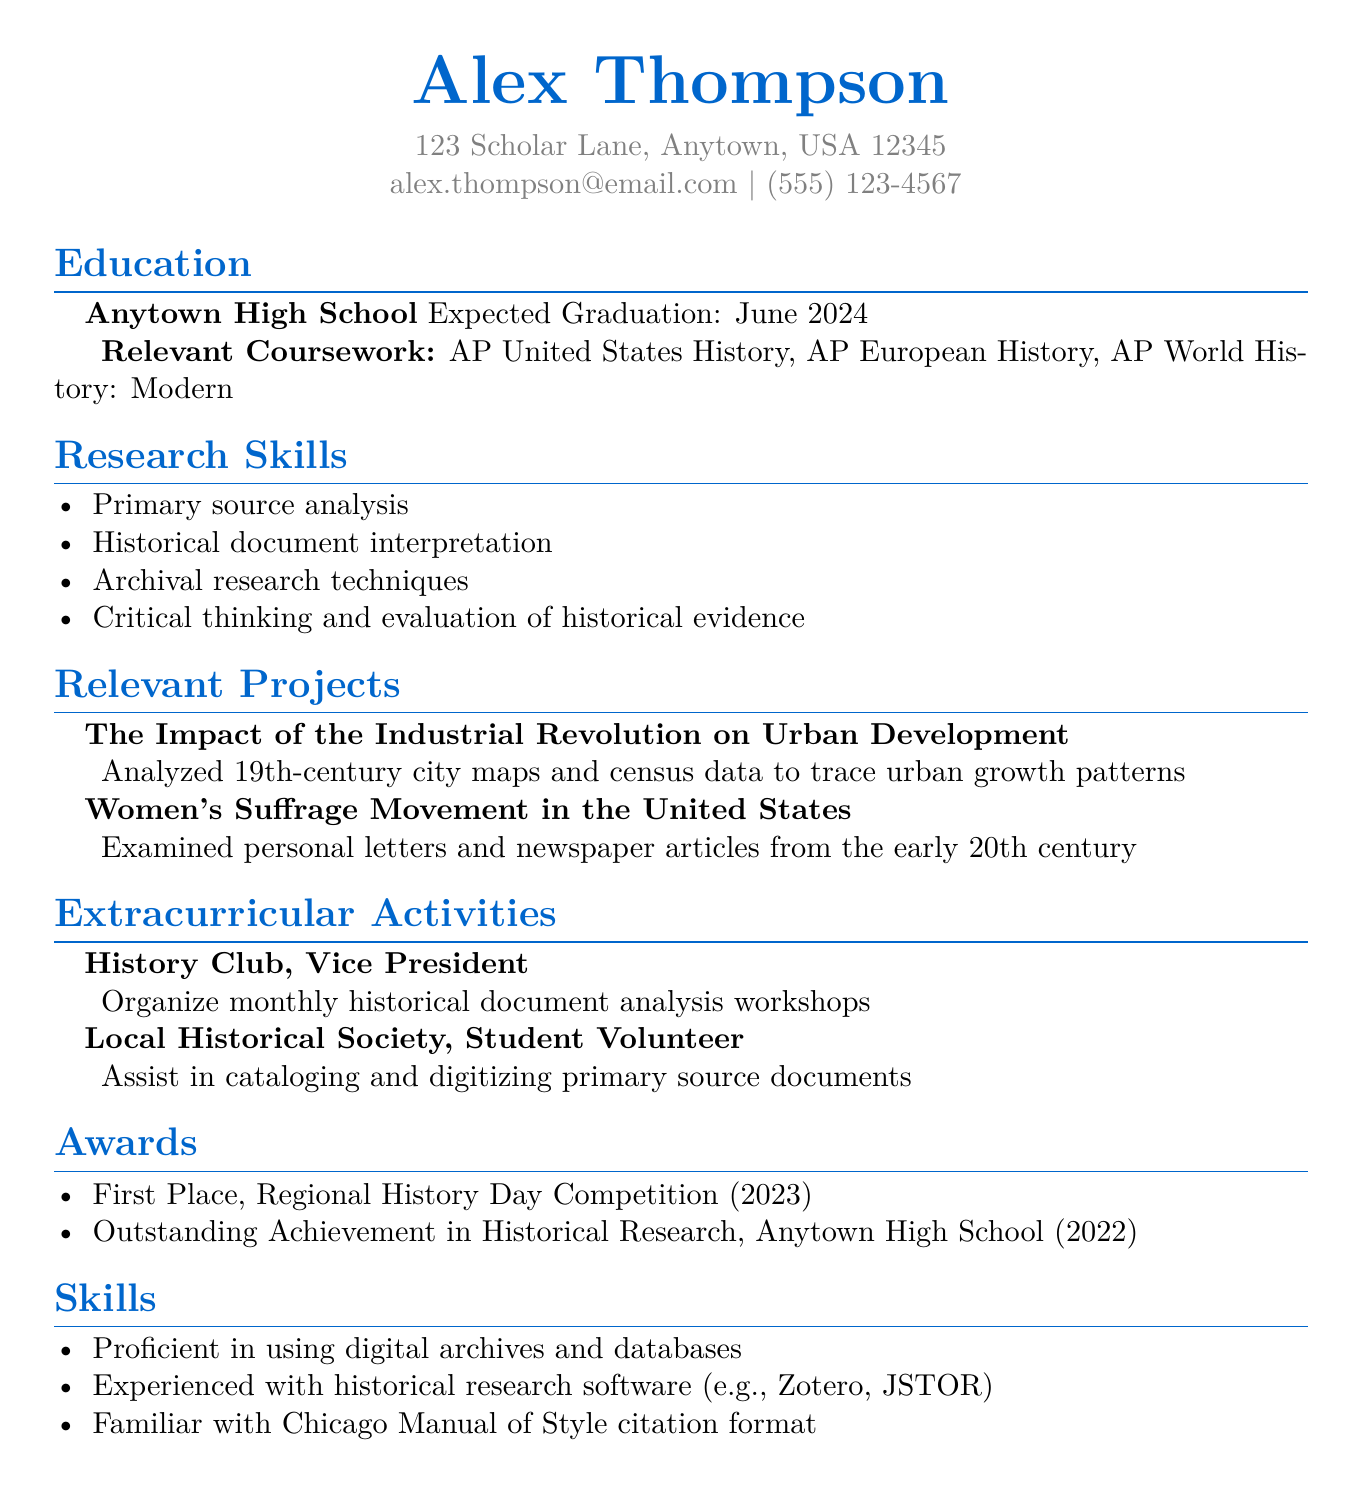What is the name of the candidate? The candidate's name is displayed prominently at the top of the document.
Answer: Alex Thompson What is the expected graduation date? The expected graduation date is provided in the education section.
Answer: June 2024 Which award did Alex Thompson receive in 2023? The awards section lists specific achievements, including the year they were won.
Answer: First Place, Regional History Day Competition What role does Alex Thompson hold in the History Club? The extracurricular activities section describes Alex's position in the club.
Answer: Vice President Name one of the skills listed in the CV. The skills section includes a list of specific competencies relevant to research.
Answer: Primary source analysis What is the title of the project related to urban development? The relevant projects section provides the titles of the projects Alex worked on.
Answer: The Impact of the Industrial Revolution on Urban Development Which software is Alex experienced with? The skills section mentions specific software relevant to historical research.
Answer: Zotero, JSTOR How many extracurricular activities are listed? The extracurricular activities section contains a specific number of entries describing Alex's involvement.
Answer: 2 